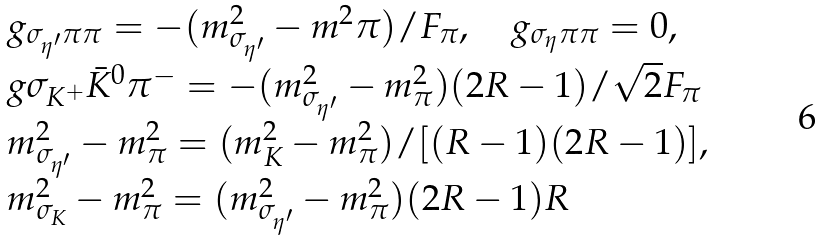<formula> <loc_0><loc_0><loc_500><loc_500>\begin{array} { l l l } g _ { \sigma _ { \eta ^ { \prime } } \pi \pi } = - ( m ^ { 2 } _ { \sigma _ { \eta ^ { \prime } } } - m ^ { 2 } { \pi } ) / F _ { \pi } , \quad g _ { \sigma _ { \eta } \pi \pi } = 0 , \\ g { \sigma _ { K ^ { + } } \bar { K } ^ { 0 } \pi ^ { - } } = - ( m ^ { 2 } _ { \sigma _ { \eta ^ { \prime } } } - m ^ { 2 } _ { \pi } ) ( 2 R - 1 ) / \sqrt { 2 } F _ { \pi } \\ m ^ { 2 } _ { \sigma _ { \eta ^ { \prime } } } - m ^ { 2 } _ { \pi } = ( m ^ { 2 } _ { K } - m ^ { 2 } _ { \pi } ) / [ ( R - 1 ) ( 2 R - 1 ) ] , \\ m ^ { 2 } _ { \sigma _ { K } } - m ^ { 2 } _ { \pi } = ( m ^ { 2 } _ { \sigma _ { \eta ^ { \prime } } } - m ^ { 2 } _ { \pi } ) ( 2 R - 1 ) R \end{array}</formula> 